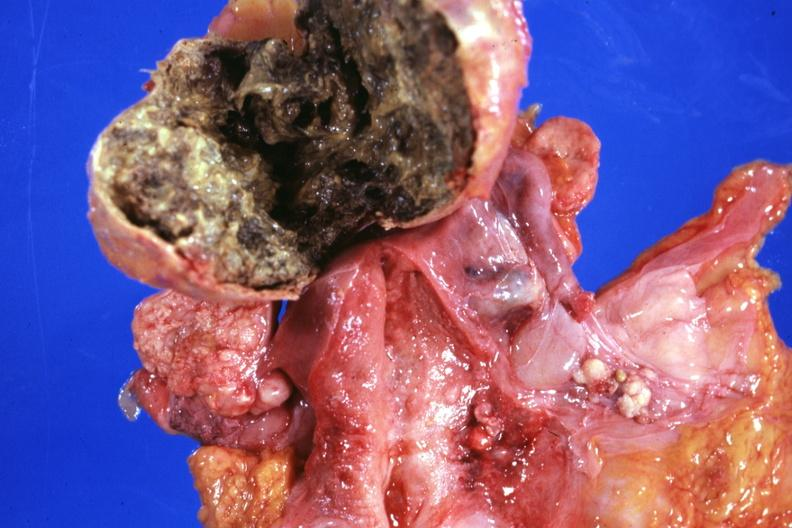s acrocyanosis present?
Answer the question using a single word or phrase. No 